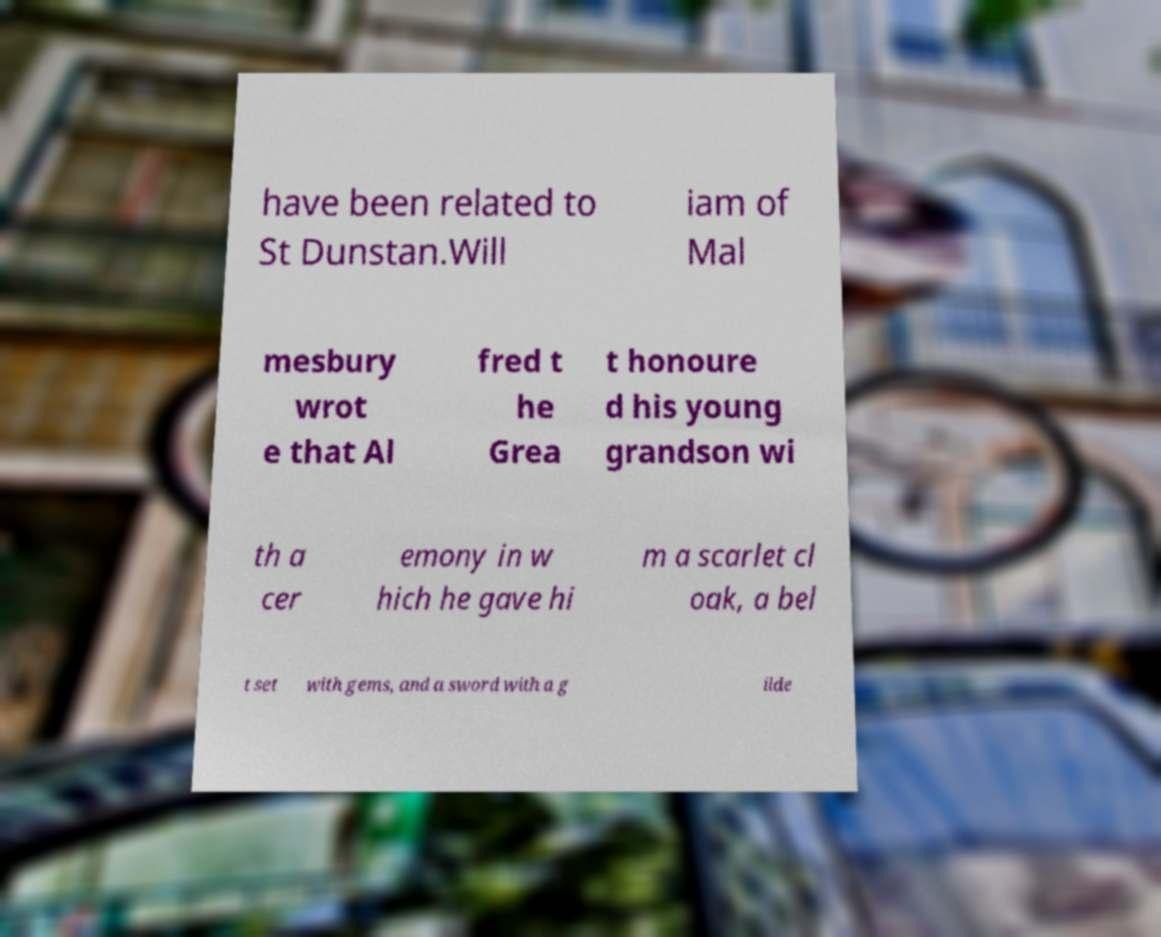For documentation purposes, I need the text within this image transcribed. Could you provide that? have been related to St Dunstan.Will iam of Mal mesbury wrot e that Al fred t he Grea t honoure d his young grandson wi th a cer emony in w hich he gave hi m a scarlet cl oak, a bel t set with gems, and a sword with a g ilde 